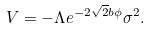Convert formula to latex. <formula><loc_0><loc_0><loc_500><loc_500>V = - \Lambda e ^ { - 2 \sqrt { 2 } b \phi } \sigma ^ { 2 } .</formula> 